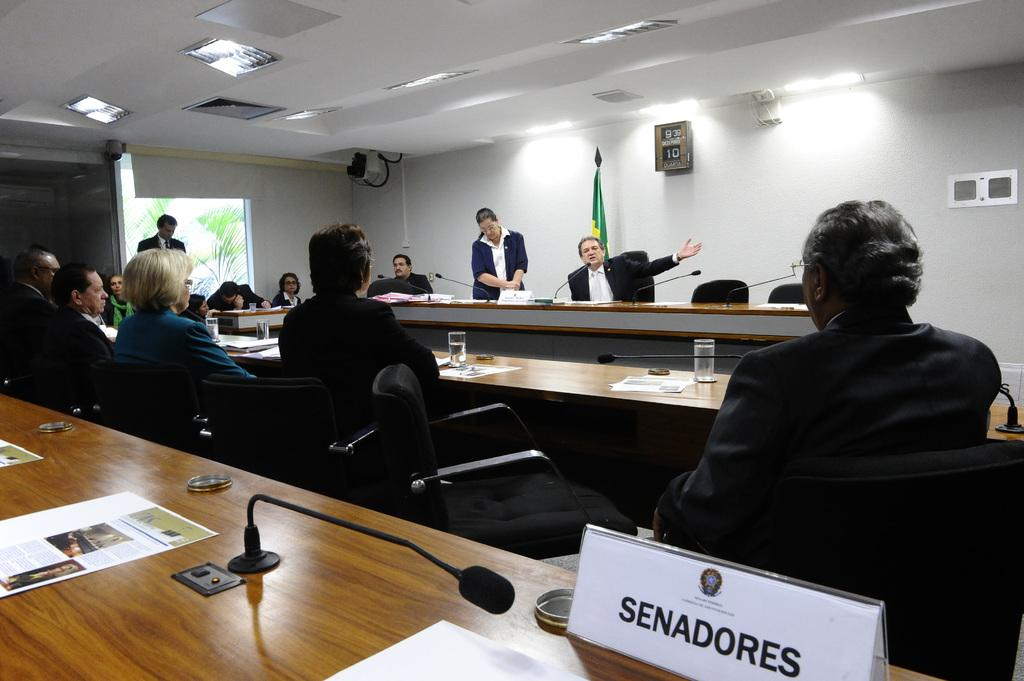<image>
Render a clear and concise summary of the photo. The word senadores can be seen on a desk with a microphone. 